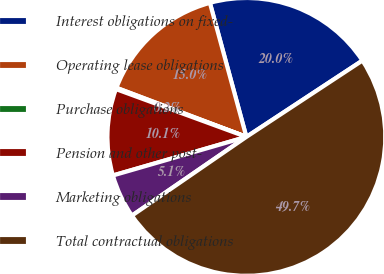Convert chart to OTSL. <chart><loc_0><loc_0><loc_500><loc_500><pie_chart><fcel>Interest obligations on fixed-<fcel>Operating lease obligations<fcel>Purchase obligations<fcel>Pension and other post-<fcel>Marketing obligations<fcel>Total contractual obligations<nl><fcel>19.97%<fcel>15.02%<fcel>0.16%<fcel>10.07%<fcel>5.11%<fcel>49.67%<nl></chart> 